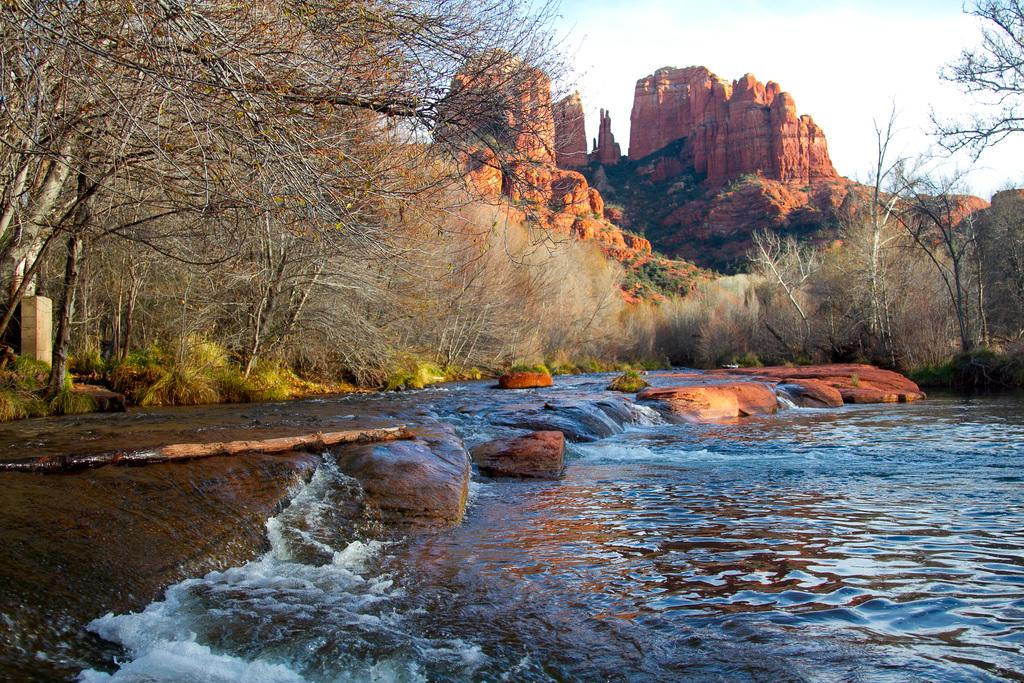What is the primary element visible in the image? There is water in the image. What type of natural vegetation can be seen in the image? There are trees in the image. What other objects are present in the image? There are rocks in the image. What is visible at the top of the image? The sky is visible at the top of the image. What type of brass hook can be seen in the image? There is no brass hook present in the image. Is there a minister in the image? There is no minister present in the image. 